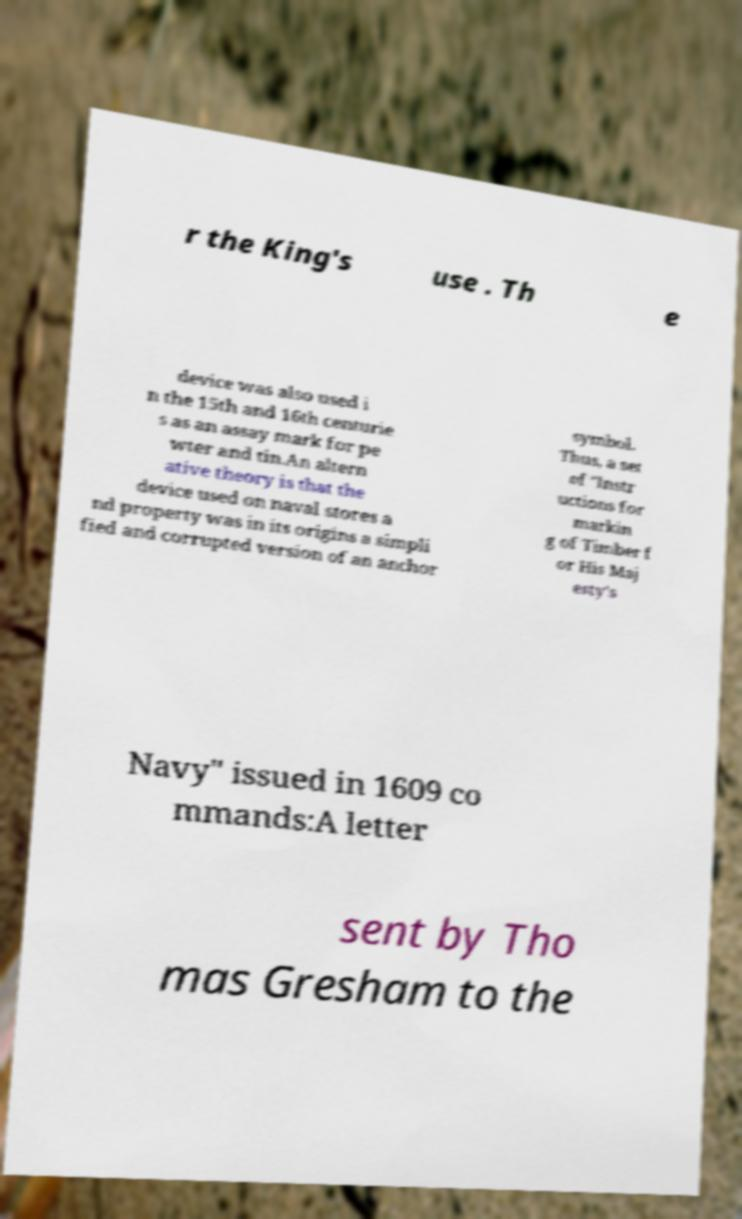For documentation purposes, I need the text within this image transcribed. Could you provide that? r the King's use . Th e device was also used i n the 15th and 16th centurie s as an assay mark for pe wter and tin.An altern ative theory is that the device used on naval stores a nd property was in its origins a simpli fied and corrupted version of an anchor symbol. Thus, a set of "Instr uctions for markin g of Timber f or His Maj esty's Navy" issued in 1609 co mmands:A letter sent by Tho mas Gresham to the 